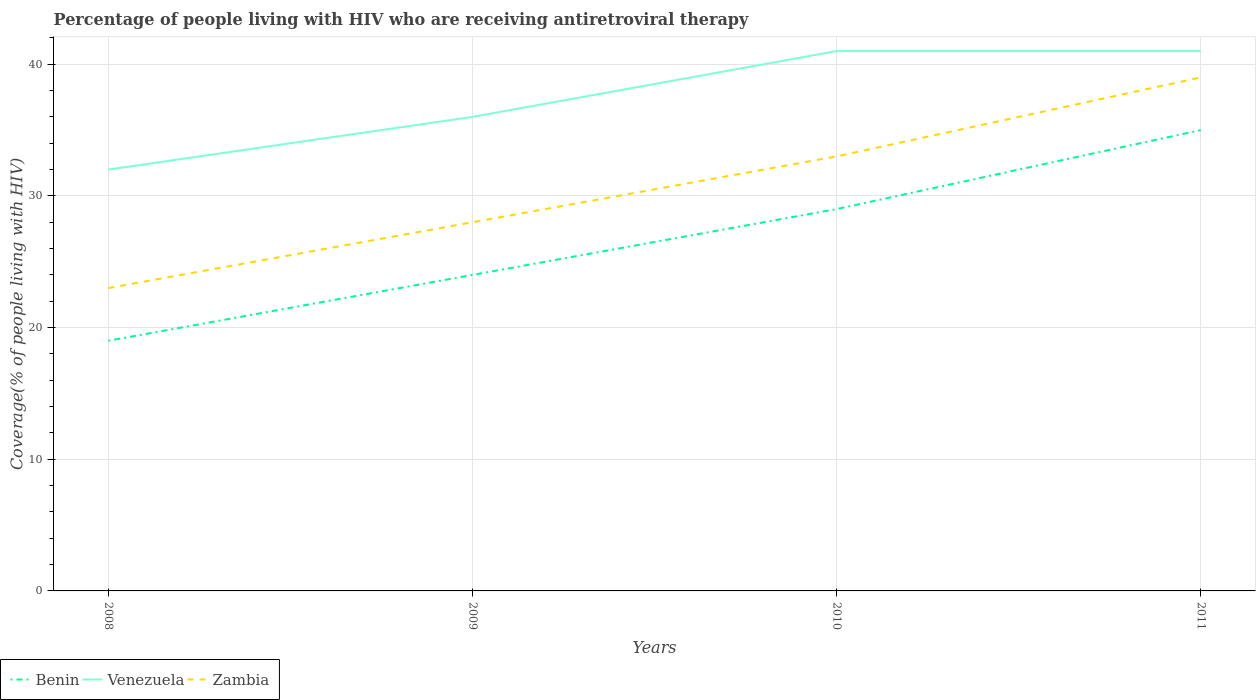Is the number of lines equal to the number of legend labels?
Ensure brevity in your answer.  Yes. Across all years, what is the maximum percentage of the HIV infected people who are receiving antiretroviral therapy in Zambia?
Make the answer very short. 23. What is the total percentage of the HIV infected people who are receiving antiretroviral therapy in Zambia in the graph?
Offer a very short reply. -11. What is the difference between the highest and the second highest percentage of the HIV infected people who are receiving antiretroviral therapy in Zambia?
Keep it short and to the point. 16. What is the difference between the highest and the lowest percentage of the HIV infected people who are receiving antiretroviral therapy in Benin?
Provide a short and direct response. 2. Is the percentage of the HIV infected people who are receiving antiretroviral therapy in Venezuela strictly greater than the percentage of the HIV infected people who are receiving antiretroviral therapy in Benin over the years?
Ensure brevity in your answer.  No. How many years are there in the graph?
Offer a terse response. 4. What is the difference between two consecutive major ticks on the Y-axis?
Make the answer very short. 10. Does the graph contain any zero values?
Your answer should be very brief. No. Does the graph contain grids?
Make the answer very short. Yes. How are the legend labels stacked?
Offer a very short reply. Horizontal. What is the title of the graph?
Provide a succinct answer. Percentage of people living with HIV who are receiving antiretroviral therapy. Does "Antigua and Barbuda" appear as one of the legend labels in the graph?
Offer a very short reply. No. What is the label or title of the Y-axis?
Provide a succinct answer. Coverage(% of people living with HIV). What is the Coverage(% of people living with HIV) of Venezuela in 2008?
Provide a succinct answer. 32. What is the Coverage(% of people living with HIV) of Benin in 2009?
Your response must be concise. 24. What is the Coverage(% of people living with HIV) of Venezuela in 2009?
Give a very brief answer. 36. What is the Coverage(% of people living with HIV) in Benin in 2010?
Ensure brevity in your answer.  29. What is the Coverage(% of people living with HIV) in Venezuela in 2010?
Provide a short and direct response. 41. What is the Coverage(% of people living with HIV) in Benin in 2011?
Your answer should be compact. 35. What is the Coverage(% of people living with HIV) of Venezuela in 2011?
Your answer should be compact. 41. What is the Coverage(% of people living with HIV) in Zambia in 2011?
Make the answer very short. 39. Across all years, what is the maximum Coverage(% of people living with HIV) in Benin?
Offer a terse response. 35. Across all years, what is the maximum Coverage(% of people living with HIV) in Venezuela?
Offer a very short reply. 41. Across all years, what is the maximum Coverage(% of people living with HIV) in Zambia?
Offer a terse response. 39. Across all years, what is the minimum Coverage(% of people living with HIV) of Venezuela?
Your answer should be very brief. 32. What is the total Coverage(% of people living with HIV) in Benin in the graph?
Offer a very short reply. 107. What is the total Coverage(% of people living with HIV) of Venezuela in the graph?
Offer a terse response. 150. What is the total Coverage(% of people living with HIV) of Zambia in the graph?
Provide a succinct answer. 123. What is the difference between the Coverage(% of people living with HIV) in Venezuela in 2008 and that in 2009?
Offer a very short reply. -4. What is the difference between the Coverage(% of people living with HIV) of Benin in 2008 and that in 2010?
Keep it short and to the point. -10. What is the difference between the Coverage(% of people living with HIV) of Venezuela in 2008 and that in 2011?
Offer a very short reply. -9. What is the difference between the Coverage(% of people living with HIV) of Benin in 2009 and that in 2010?
Ensure brevity in your answer.  -5. What is the difference between the Coverage(% of people living with HIV) of Benin in 2009 and that in 2011?
Provide a succinct answer. -11. What is the difference between the Coverage(% of people living with HIV) in Venezuela in 2009 and that in 2011?
Offer a very short reply. -5. What is the difference between the Coverage(% of people living with HIV) of Benin in 2008 and the Coverage(% of people living with HIV) of Zambia in 2009?
Your answer should be compact. -9. What is the difference between the Coverage(% of people living with HIV) in Venezuela in 2008 and the Coverage(% of people living with HIV) in Zambia in 2009?
Keep it short and to the point. 4. What is the difference between the Coverage(% of people living with HIV) in Venezuela in 2008 and the Coverage(% of people living with HIV) in Zambia in 2010?
Make the answer very short. -1. What is the difference between the Coverage(% of people living with HIV) in Benin in 2008 and the Coverage(% of people living with HIV) in Zambia in 2011?
Keep it short and to the point. -20. What is the difference between the Coverage(% of people living with HIV) of Venezuela in 2008 and the Coverage(% of people living with HIV) of Zambia in 2011?
Your answer should be compact. -7. What is the difference between the Coverage(% of people living with HIV) of Benin in 2009 and the Coverage(% of people living with HIV) of Venezuela in 2011?
Your answer should be compact. -17. What is the difference between the Coverage(% of people living with HIV) in Benin in 2009 and the Coverage(% of people living with HIV) in Zambia in 2011?
Make the answer very short. -15. What is the difference between the Coverage(% of people living with HIV) in Venezuela in 2009 and the Coverage(% of people living with HIV) in Zambia in 2011?
Offer a terse response. -3. What is the difference between the Coverage(% of people living with HIV) in Benin in 2010 and the Coverage(% of people living with HIV) in Venezuela in 2011?
Provide a short and direct response. -12. What is the average Coverage(% of people living with HIV) in Benin per year?
Your response must be concise. 26.75. What is the average Coverage(% of people living with HIV) of Venezuela per year?
Keep it short and to the point. 37.5. What is the average Coverage(% of people living with HIV) of Zambia per year?
Your answer should be very brief. 30.75. In the year 2008, what is the difference between the Coverage(% of people living with HIV) in Benin and Coverage(% of people living with HIV) in Venezuela?
Offer a very short reply. -13. In the year 2009, what is the difference between the Coverage(% of people living with HIV) of Benin and Coverage(% of people living with HIV) of Venezuela?
Keep it short and to the point. -12. In the year 2009, what is the difference between the Coverage(% of people living with HIV) in Benin and Coverage(% of people living with HIV) in Zambia?
Provide a short and direct response. -4. In the year 2009, what is the difference between the Coverage(% of people living with HIV) in Venezuela and Coverage(% of people living with HIV) in Zambia?
Keep it short and to the point. 8. In the year 2011, what is the difference between the Coverage(% of people living with HIV) in Benin and Coverage(% of people living with HIV) in Venezuela?
Your answer should be compact. -6. In the year 2011, what is the difference between the Coverage(% of people living with HIV) in Benin and Coverage(% of people living with HIV) in Zambia?
Your answer should be compact. -4. What is the ratio of the Coverage(% of people living with HIV) in Benin in 2008 to that in 2009?
Offer a very short reply. 0.79. What is the ratio of the Coverage(% of people living with HIV) in Zambia in 2008 to that in 2009?
Provide a short and direct response. 0.82. What is the ratio of the Coverage(% of people living with HIV) in Benin in 2008 to that in 2010?
Your answer should be very brief. 0.66. What is the ratio of the Coverage(% of people living with HIV) of Venezuela in 2008 to that in 2010?
Give a very brief answer. 0.78. What is the ratio of the Coverage(% of people living with HIV) in Zambia in 2008 to that in 2010?
Provide a succinct answer. 0.7. What is the ratio of the Coverage(% of people living with HIV) of Benin in 2008 to that in 2011?
Provide a succinct answer. 0.54. What is the ratio of the Coverage(% of people living with HIV) in Venezuela in 2008 to that in 2011?
Your answer should be very brief. 0.78. What is the ratio of the Coverage(% of people living with HIV) of Zambia in 2008 to that in 2011?
Your response must be concise. 0.59. What is the ratio of the Coverage(% of people living with HIV) of Benin in 2009 to that in 2010?
Give a very brief answer. 0.83. What is the ratio of the Coverage(% of people living with HIV) in Venezuela in 2009 to that in 2010?
Provide a succinct answer. 0.88. What is the ratio of the Coverage(% of people living with HIV) of Zambia in 2009 to that in 2010?
Give a very brief answer. 0.85. What is the ratio of the Coverage(% of people living with HIV) in Benin in 2009 to that in 2011?
Your answer should be compact. 0.69. What is the ratio of the Coverage(% of people living with HIV) in Venezuela in 2009 to that in 2011?
Your response must be concise. 0.88. What is the ratio of the Coverage(% of people living with HIV) of Zambia in 2009 to that in 2011?
Offer a terse response. 0.72. What is the ratio of the Coverage(% of people living with HIV) of Benin in 2010 to that in 2011?
Provide a short and direct response. 0.83. What is the ratio of the Coverage(% of people living with HIV) of Zambia in 2010 to that in 2011?
Your answer should be compact. 0.85. What is the difference between the highest and the lowest Coverage(% of people living with HIV) of Venezuela?
Give a very brief answer. 9. What is the difference between the highest and the lowest Coverage(% of people living with HIV) of Zambia?
Your answer should be compact. 16. 